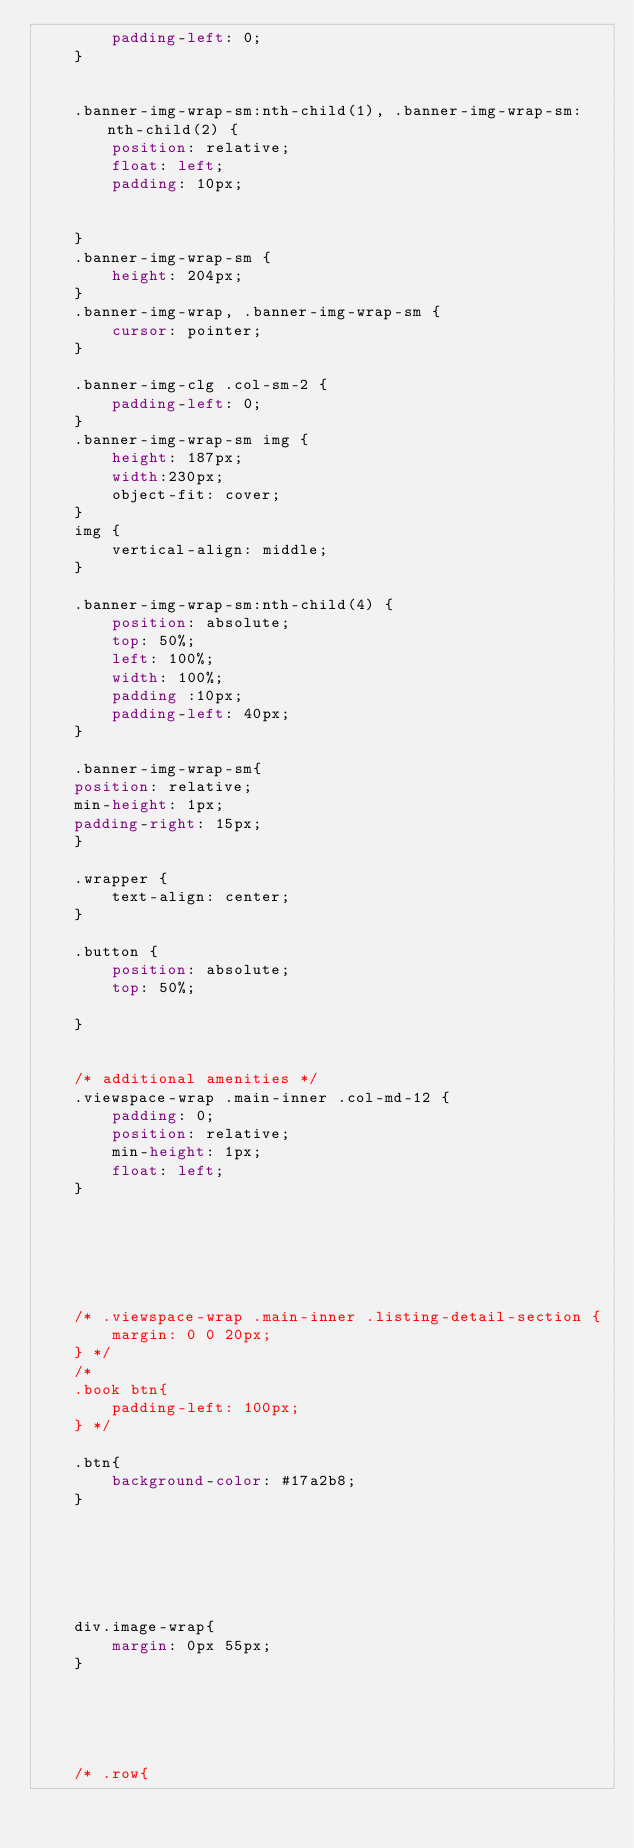Convert code to text. <code><loc_0><loc_0><loc_500><loc_500><_CSS_>        padding-left: 0;
    }
    
    
    .banner-img-wrap-sm:nth-child(1), .banner-img-wrap-sm:nth-child(2) {
        position: relative;
        float: left;
        padding: 10px;
      
       
    }
    .banner-img-wrap-sm {
        height: 204px;
    }
    .banner-img-wrap, .banner-img-wrap-sm {
        cursor: pointer;
    }
    
    .banner-img-clg .col-sm-2 {
        padding-left: 0;
    }
    .banner-img-wrap-sm img {
        height: 187px;
        width:230px;
        object-fit: cover;
    }
    img {
        vertical-align: middle;
    }
    
    .banner-img-wrap-sm:nth-child(4) {
        position: absolute;
        top: 50%;
        left: 100%;
        width: 100%;
        padding :10px;
        padding-left: 40px;
    }
    
    .banner-img-wrap-sm{
    position: relative;
    min-height: 1px;
    padding-right: 15px;
    }
    
    .wrapper {
        text-align: center;
    }
    
    .button {
        position: absolute;
        top: 50%;
        
    }
    
    
    /* additional amenities */
    .viewspace-wrap .main-inner .col-md-12 {
        padding: 0;
        position: relative;
        min-height: 1px;
        float: left;
    }
    
    
    
    
    
    
    /* .viewspace-wrap .main-inner .listing-detail-section {
        margin: 0 0 20px;
    } */
    /* 
    .book btn{
        padding-left: 100px;
    } */
    
    .btn{
        background-color: #17a2b8;
    }
    
    
    
    
    
    
    div.image-wrap{
        margin: 0px 55px;
    }
    
    
    
    
    
    /* .row{</code> 